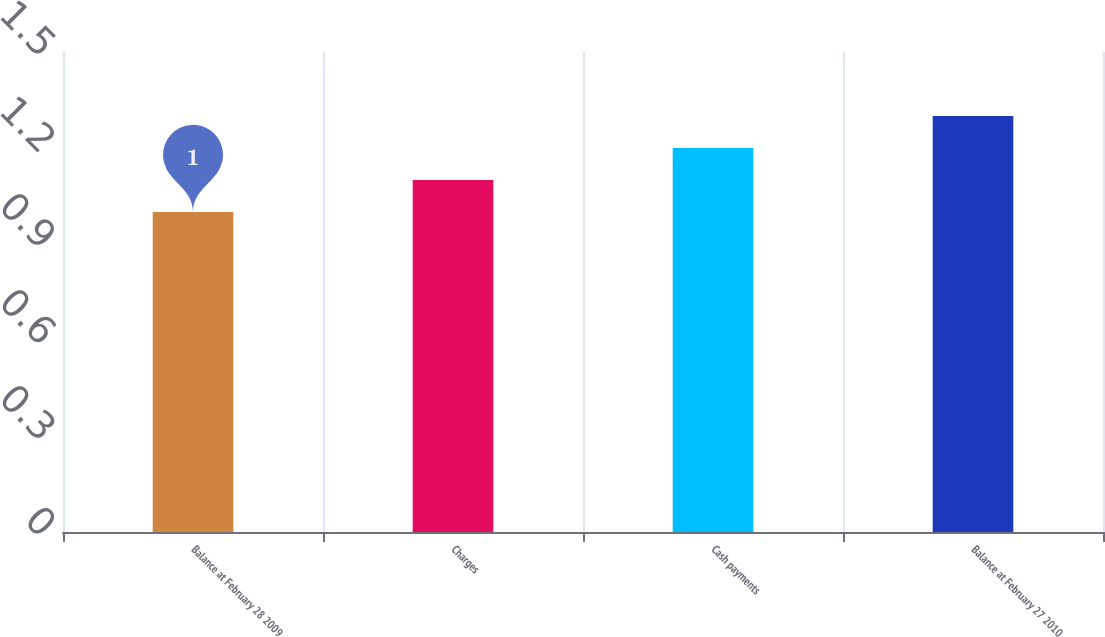<chart> <loc_0><loc_0><loc_500><loc_500><bar_chart><fcel>Balance at February 28 2009<fcel>Charges<fcel>Cash payments<fcel>Balance at February 27 2010<nl><fcel>1<fcel>1.1<fcel>1.2<fcel>1.3<nl></chart> 